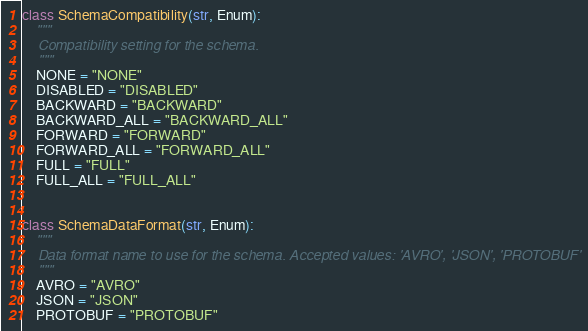<code> <loc_0><loc_0><loc_500><loc_500><_Python_>

class SchemaCompatibility(str, Enum):
    """
    Compatibility setting for the schema.
    """
    NONE = "NONE"
    DISABLED = "DISABLED"
    BACKWARD = "BACKWARD"
    BACKWARD_ALL = "BACKWARD_ALL"
    FORWARD = "FORWARD"
    FORWARD_ALL = "FORWARD_ALL"
    FULL = "FULL"
    FULL_ALL = "FULL_ALL"


class SchemaDataFormat(str, Enum):
    """
    Data format name to use for the schema. Accepted values: 'AVRO', 'JSON', 'PROTOBUF'
    """
    AVRO = "AVRO"
    JSON = "JSON"
    PROTOBUF = "PROTOBUF"
</code> 